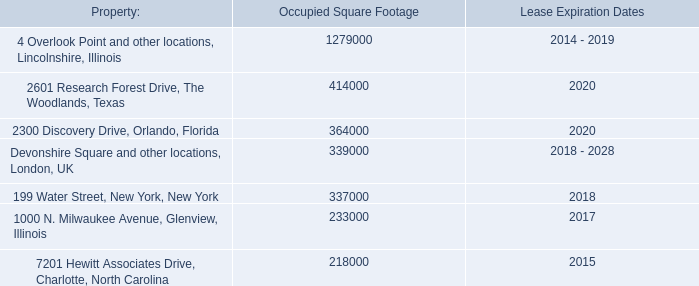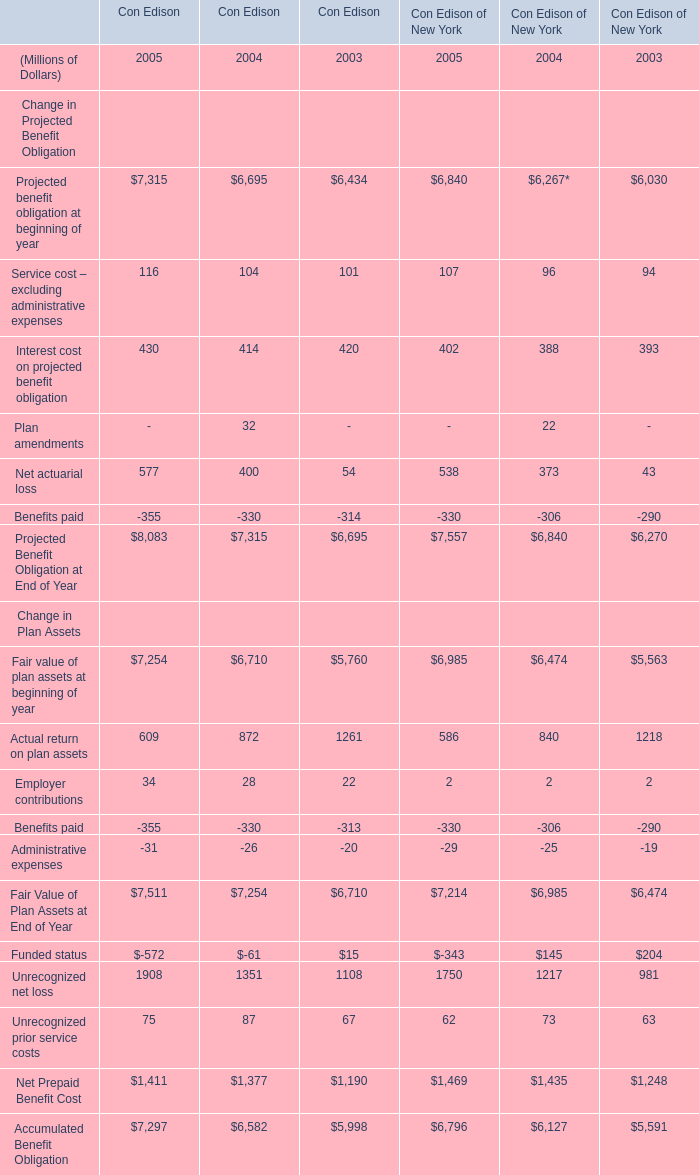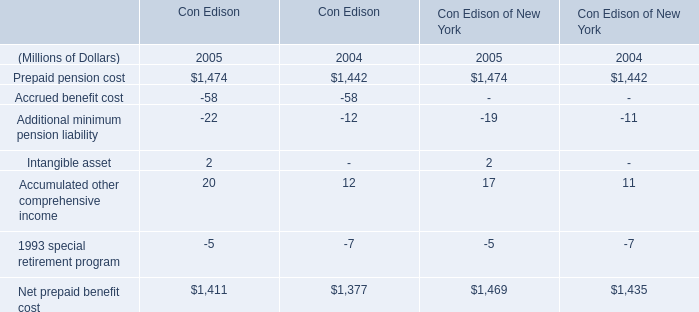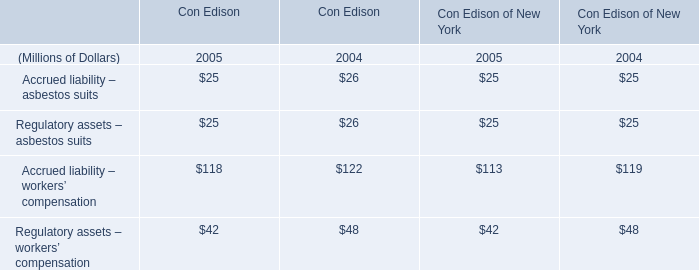Which year / section is Prepaid pension cost the highest? 
Answer: 2005. 